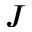<formula> <loc_0><loc_0><loc_500><loc_500>J</formula> 